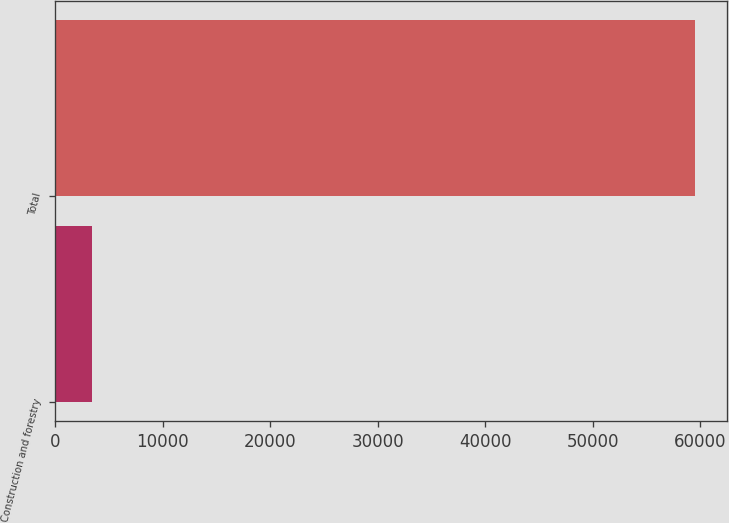<chart> <loc_0><loc_0><loc_500><loc_500><bar_chart><fcel>Construction and forestry<fcel>Total<nl><fcel>3461<fcel>59521<nl></chart> 